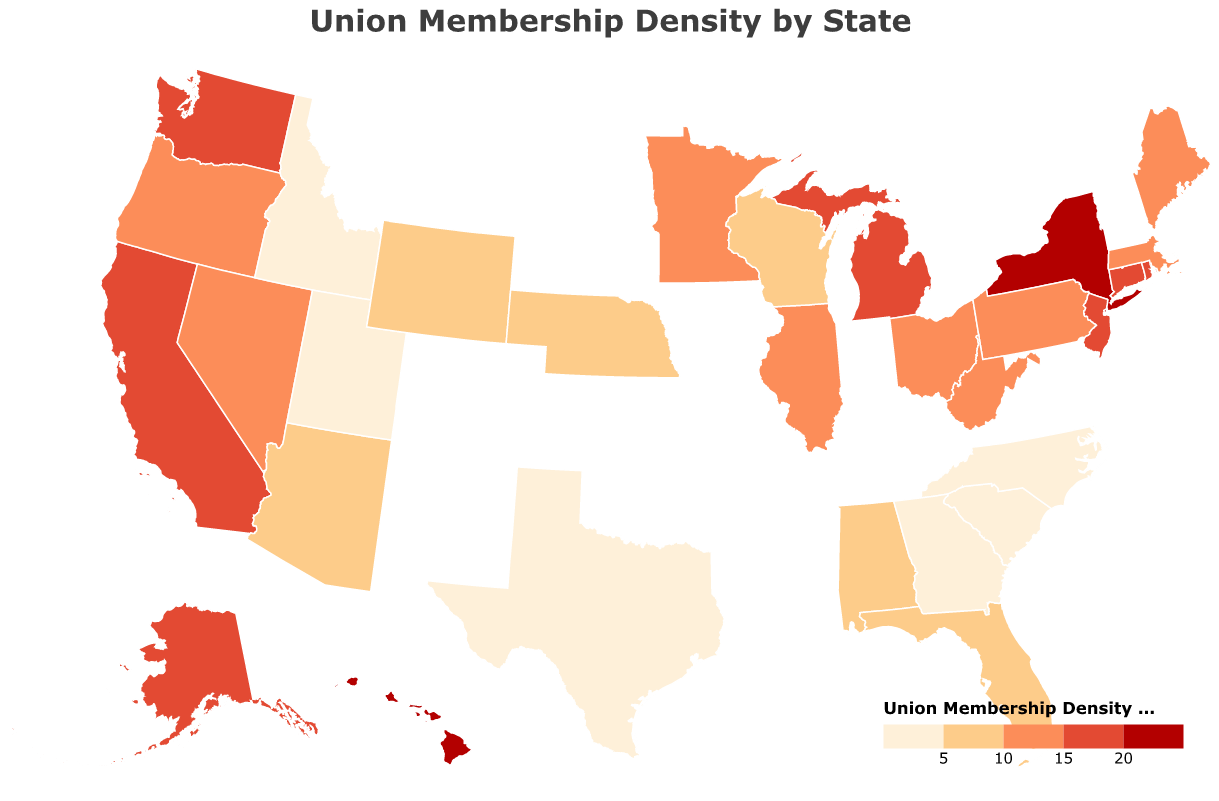What is the title of the figure? The title is located at the top of the figure and serves to describe the content of the plot. It reads "Union Membership Density by State".
Answer: Union Membership Density by State Which state has the highest union membership density? By interpreting the color legend, the darkest color indicates the highest density. New York has the highest density percentage shown as 23.2%.
Answer: New York How does the union membership density in New York compare to California? The union membership density in New York is 23.2%, and in California, it is 16.1%. 23.2% is greater than 16.1%.
Answer: New York has a higher density than California List the states with union membership density greater than 15%. To identify these states, look for those colored in the two darkest shades of the legend. States include New York, California, Washington, Alaska, Hawaii, Rhode Island, and Connecticut.
Answer: New York, California, Washington, Alaska, Hawaii, Rhode Island, Connecticut What is the difference in union membership density between Illinois and Ohio? Illinois has a union membership density of 13.8%, and Ohio has 13.0%. Subtract Ohio's density from Illinois’ density, which is 13.8% - 13.0% = 0.8%.
Answer: 0.8% Identify the state with the lowest union membership density. The state with the lightest color (indicating the lowest density on the color scale) is South Carolina, with 2.9%.
Answer: South Carolina What is the average union membership density of the western states: California, Washington, and Oregon? The densities are: California (16.1%), Washington (17.4%), and Oregon (14.9%). Average = (16.1 + 17.4 + 14.9) / 3 ≈ 16.13%.
Answer: 16.13% Compare the union membership density of the highest and lowest states. What is the percentage difference? The highest is New York at 23.2%, and the lowest is South Carolina at 2.9%. The difference = 23.2% - 2.9% = 20.3%.
Answer: 20.3% Which regions of the US (Northeast, Midwest, West, South) generally show higher union membership densities? By observing the color gradient, the Northeast and West regions have more states with darker colors indicating higher densities. Southern states generally have lower densities.
Answer: Northeast and West 